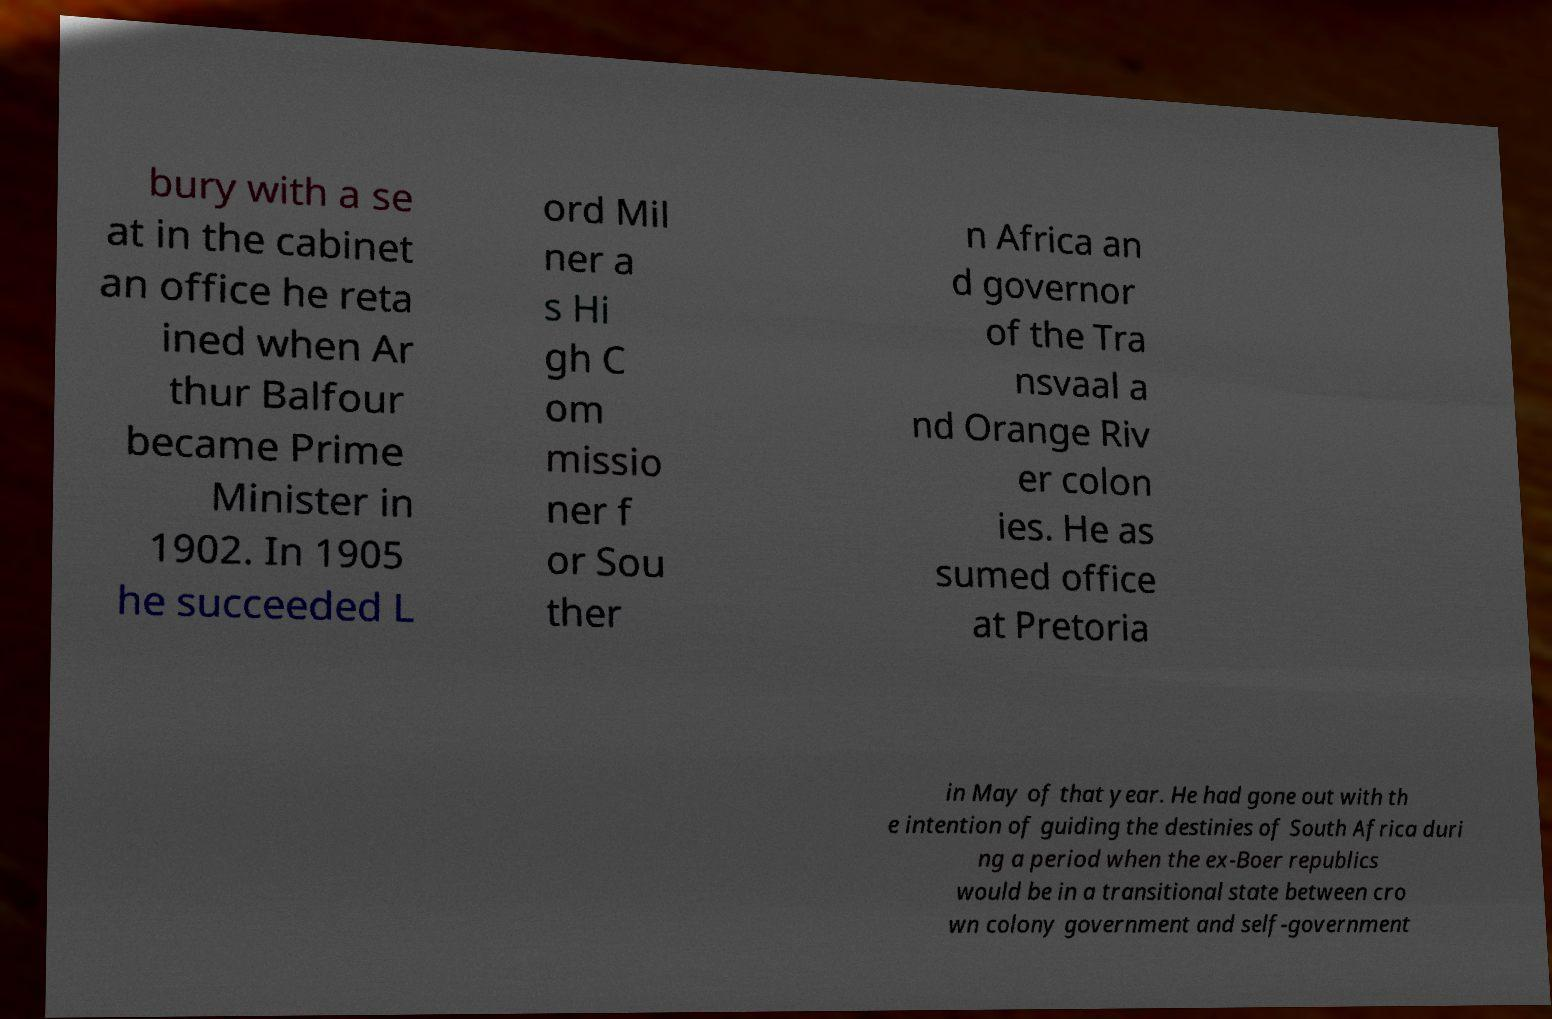Please read and relay the text visible in this image. What does it say? bury with a se at in the cabinet an office he reta ined when Ar thur Balfour became Prime Minister in 1902. In 1905 he succeeded L ord Mil ner a s Hi gh C om missio ner f or Sou ther n Africa an d governor of the Tra nsvaal a nd Orange Riv er colon ies. He as sumed office at Pretoria in May of that year. He had gone out with th e intention of guiding the destinies of South Africa duri ng a period when the ex-Boer republics would be in a transitional state between cro wn colony government and self-government 